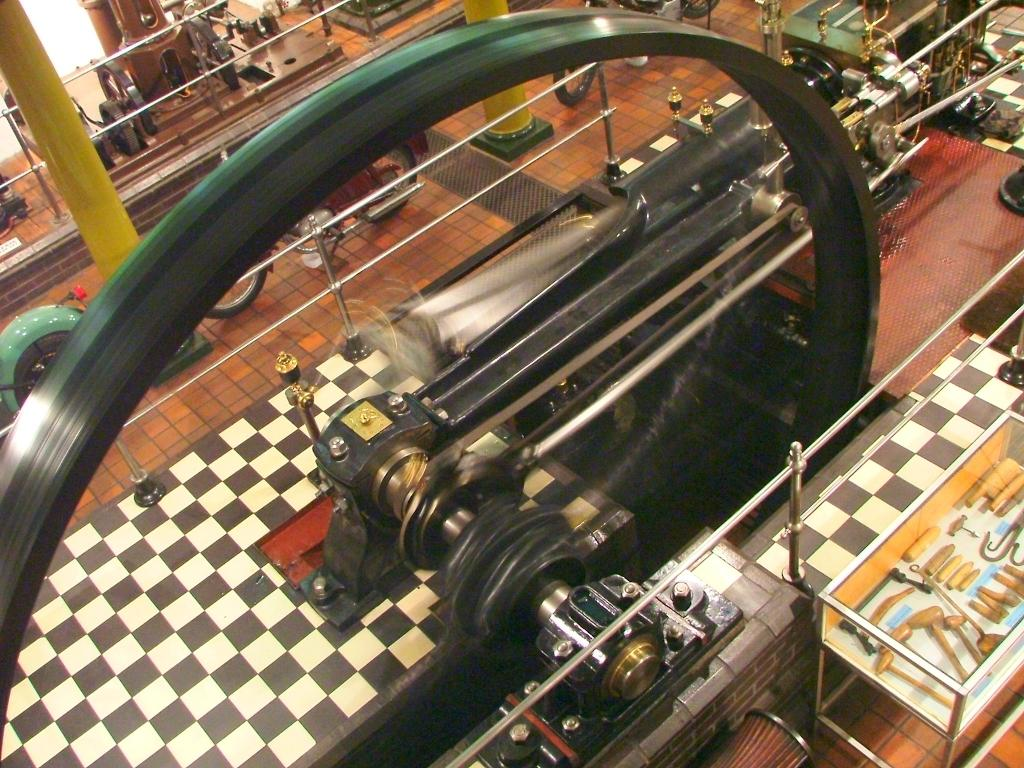What is the main object in the image? There is a machine in the image. What is happening with the machine? A wheel is running on the machine. What else can be seen on the floor? There are motorcycles on the floor. Where are the wooden tools located? The wooden tools are present in a glass box. What architectural features are visible in the image? There are pillars in the image. How many boats are present in the image? There are no boats visible in the image. What type of match is being played in the image? There is no match being played in the image; it features a machine, motorcycles, and wooden tools. 